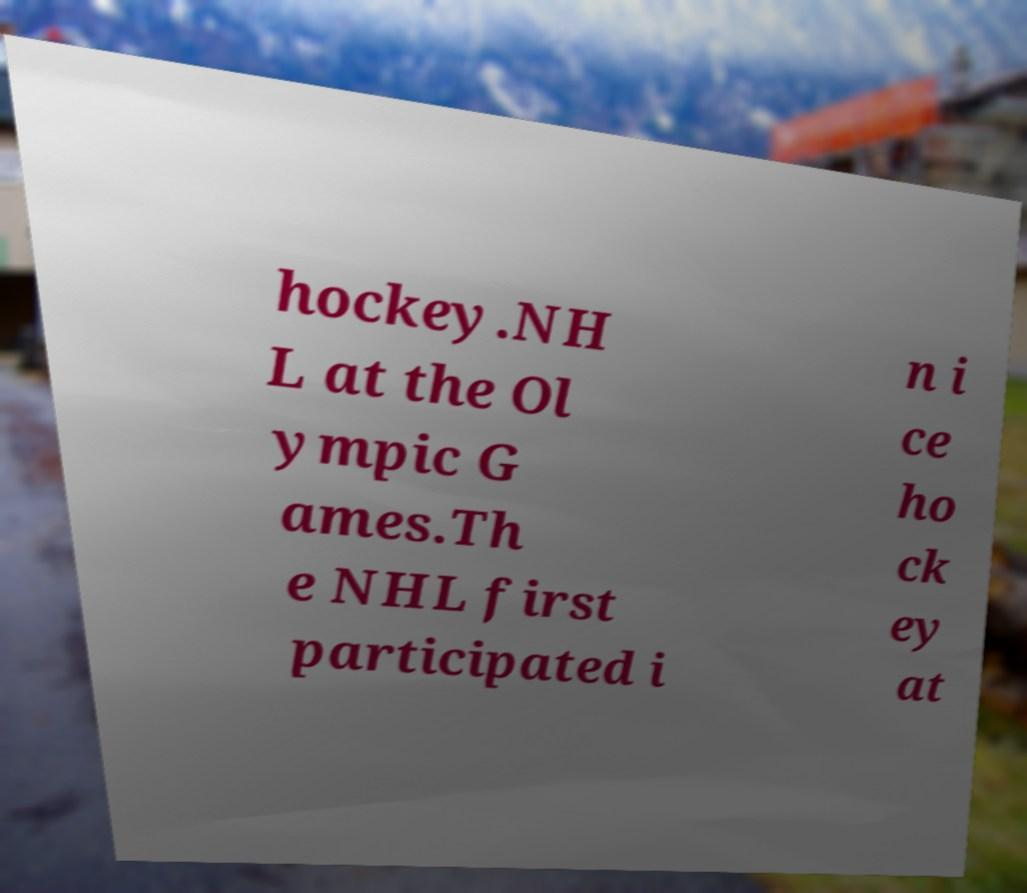I need the written content from this picture converted into text. Can you do that? hockey.NH L at the Ol ympic G ames.Th e NHL first participated i n i ce ho ck ey at 